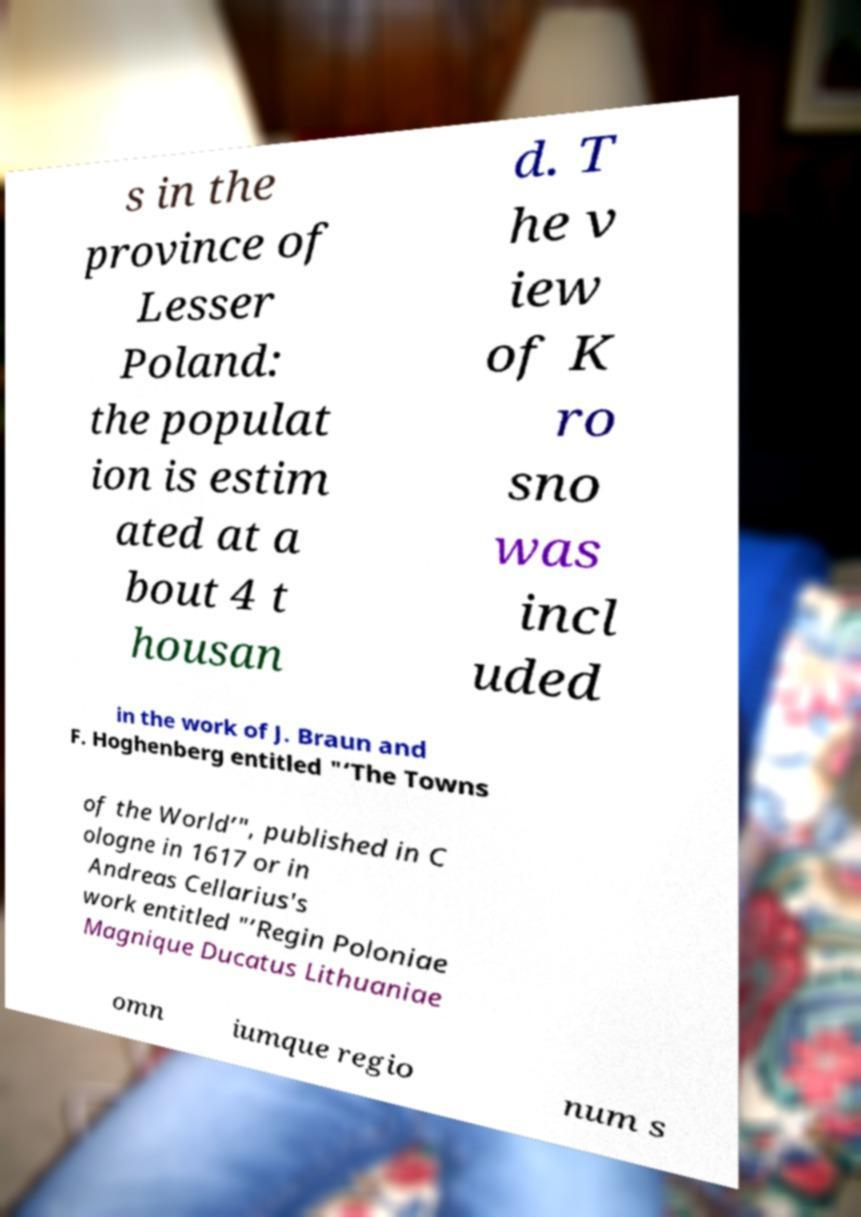Can you accurately transcribe the text from the provided image for me? s in the province of Lesser Poland: the populat ion is estim ated at a bout 4 t housan d. T he v iew of K ro sno was incl uded in the work of J. Braun and F. Hoghenberg entitled "‘The Towns of the World’", published in C ologne in 1617 or in Andreas Cellarius's work entitled "‘Regin Poloniae Magnique Ducatus Lithuaniae omn iumque regio num s 